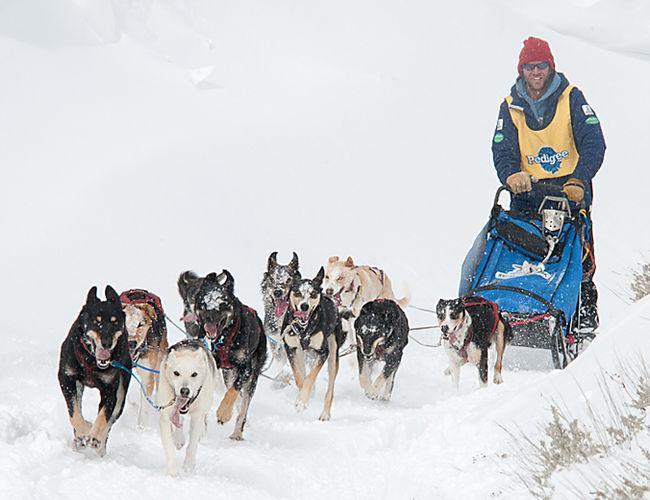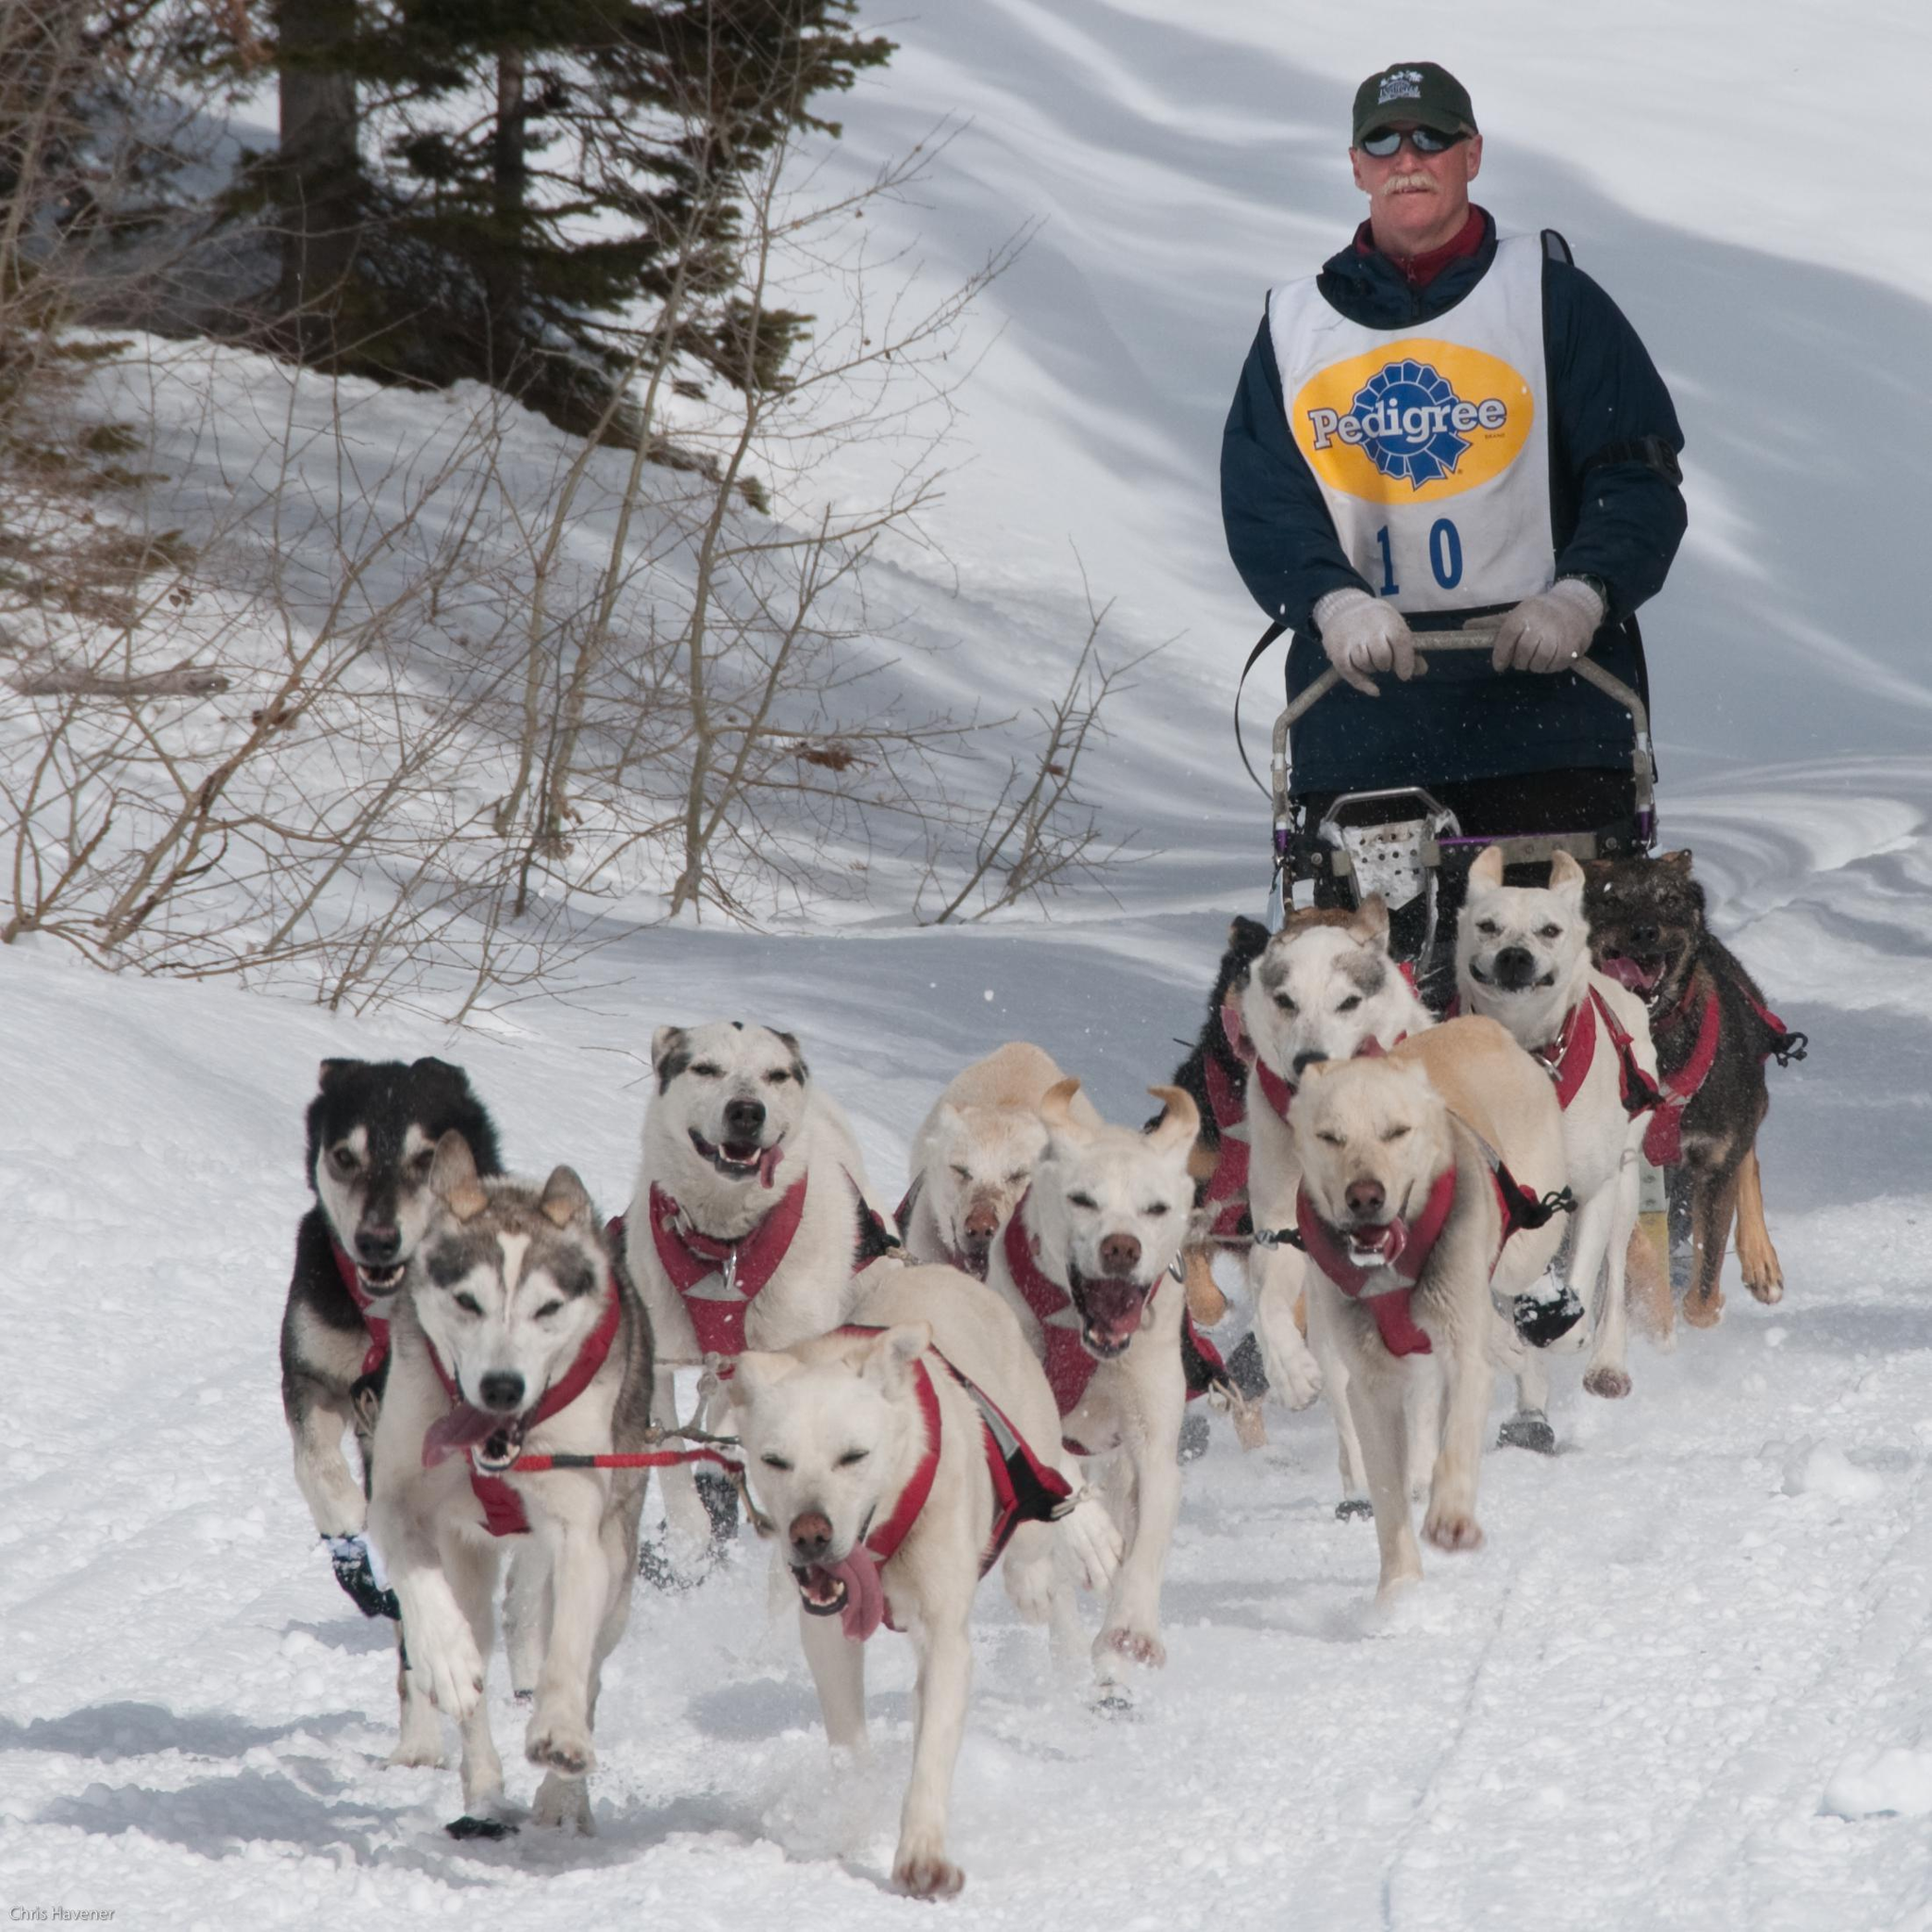The first image is the image on the left, the second image is the image on the right. For the images displayed, is the sentence "At least one of the drivers is wearing yellow." factually correct? Answer yes or no. Yes. The first image is the image on the left, the second image is the image on the right. Assess this claim about the two images: "Two or fewer humans are visible.". Correct or not? Answer yes or no. Yes. 